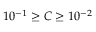<formula> <loc_0><loc_0><loc_500><loc_500>1 0 ^ { - 1 } \geq C \geq 1 0 ^ { - 2 }</formula> 